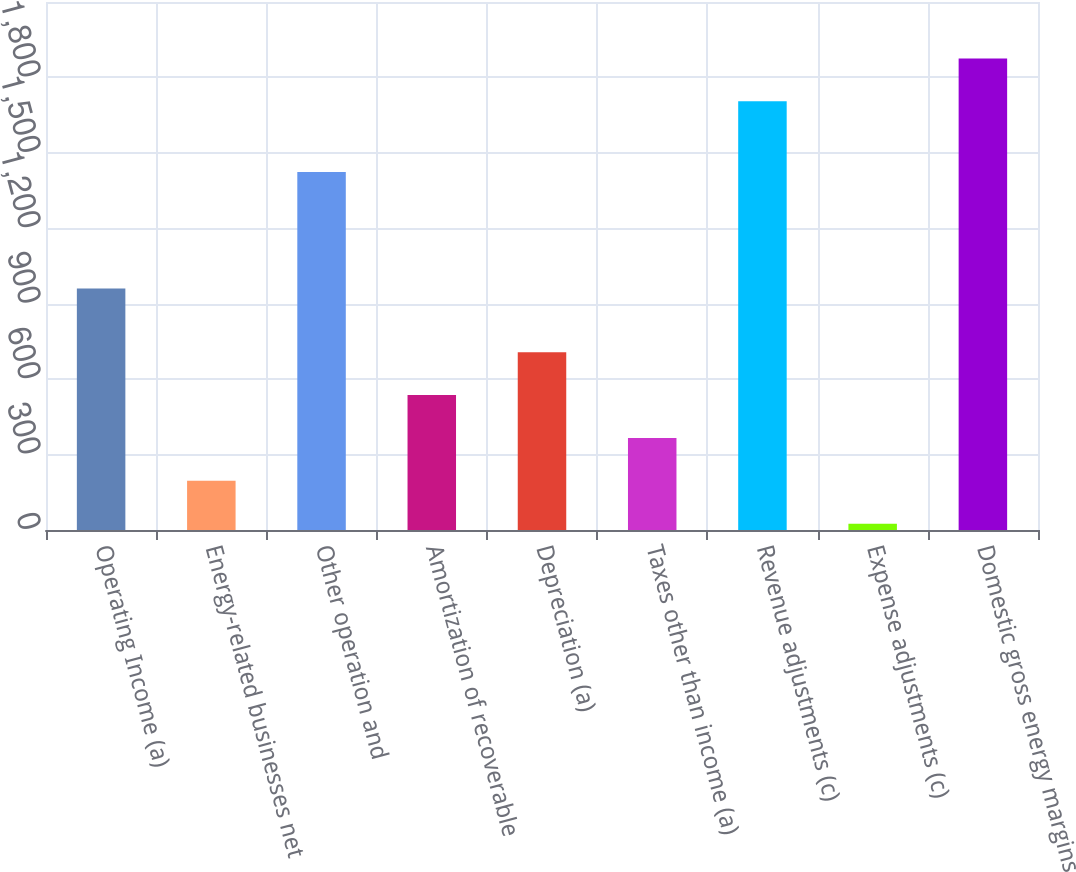Convert chart. <chart><loc_0><loc_0><loc_500><loc_500><bar_chart><fcel>Operating Income (a)<fcel>Energy-related businesses net<fcel>Other operation and<fcel>Amortization of recoverable<fcel>Depreciation (a)<fcel>Taxes other than income (a)<fcel>Revenue adjustments (c)<fcel>Expense adjustments (c)<fcel>Domestic gross energy margins<nl><fcel>961<fcel>195.6<fcel>1424<fcel>536.8<fcel>707.4<fcel>366.2<fcel>1705<fcel>25<fcel>1875.6<nl></chart> 